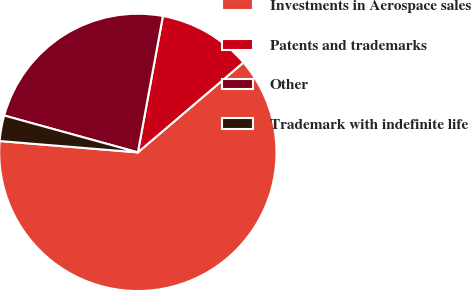Convert chart to OTSL. <chart><loc_0><loc_0><loc_500><loc_500><pie_chart><fcel>Investments in Aerospace sales<fcel>Patents and trademarks<fcel>Other<fcel>Trademark with indefinite life<nl><fcel>62.53%<fcel>10.88%<fcel>23.61%<fcel>2.98%<nl></chart> 